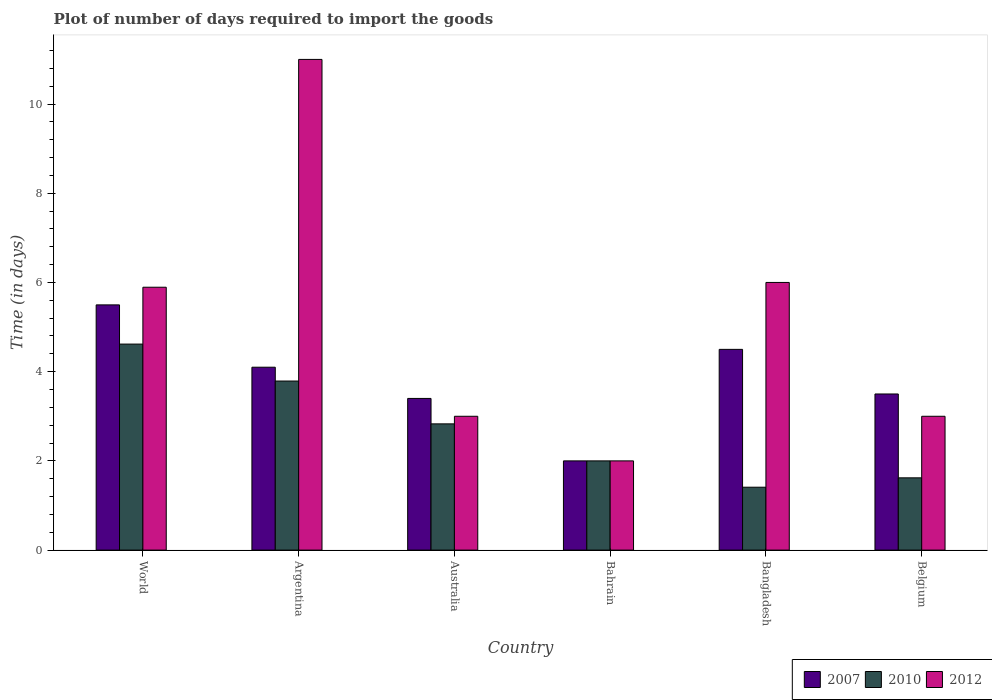How many different coloured bars are there?
Offer a terse response. 3. How many groups of bars are there?
Ensure brevity in your answer.  6. Are the number of bars per tick equal to the number of legend labels?
Keep it short and to the point. Yes. Are the number of bars on each tick of the X-axis equal?
Your response must be concise. Yes. What is the label of the 2nd group of bars from the left?
Offer a terse response. Argentina. What is the time required to import goods in 2010 in Belgium?
Provide a succinct answer. 1.62. Across all countries, what is the maximum time required to import goods in 2012?
Keep it short and to the point. 11. Across all countries, what is the minimum time required to import goods in 2010?
Your answer should be very brief. 1.41. In which country was the time required to import goods in 2012 minimum?
Your response must be concise. Bahrain. What is the total time required to import goods in 2010 in the graph?
Keep it short and to the point. 16.27. What is the difference between the time required to import goods in 2012 in Bahrain and that in Belgium?
Provide a succinct answer. -1. What is the difference between the time required to import goods in 2007 in Bangladesh and the time required to import goods in 2012 in World?
Provide a succinct answer. -1.39. What is the average time required to import goods in 2010 per country?
Ensure brevity in your answer.  2.71. What is the difference between the time required to import goods of/in 2010 and time required to import goods of/in 2007 in Australia?
Provide a succinct answer. -0.57. In how many countries, is the time required to import goods in 2007 greater than 1.6 days?
Your answer should be compact. 6. What is the ratio of the time required to import goods in 2010 in Bangladesh to that in Belgium?
Your answer should be very brief. 0.87. Is the time required to import goods in 2010 in Australia less than that in Bahrain?
Make the answer very short. No. Is the difference between the time required to import goods in 2010 in Argentina and Belgium greater than the difference between the time required to import goods in 2007 in Argentina and Belgium?
Provide a succinct answer. Yes. What is the difference between the highest and the second highest time required to import goods in 2010?
Provide a succinct answer. -0.96. What is the difference between the highest and the lowest time required to import goods in 2010?
Ensure brevity in your answer.  3.21. In how many countries, is the time required to import goods in 2007 greater than the average time required to import goods in 2007 taken over all countries?
Offer a terse response. 3. Is it the case that in every country, the sum of the time required to import goods in 2010 and time required to import goods in 2012 is greater than the time required to import goods in 2007?
Offer a terse response. Yes. How many countries are there in the graph?
Keep it short and to the point. 6. What is the difference between two consecutive major ticks on the Y-axis?
Your answer should be compact. 2. Does the graph contain any zero values?
Your response must be concise. No. Does the graph contain grids?
Ensure brevity in your answer.  No. Where does the legend appear in the graph?
Offer a terse response. Bottom right. What is the title of the graph?
Provide a short and direct response. Plot of number of days required to import the goods. What is the label or title of the X-axis?
Your response must be concise. Country. What is the label or title of the Y-axis?
Keep it short and to the point. Time (in days). What is the Time (in days) of 2007 in World?
Give a very brief answer. 5.5. What is the Time (in days) of 2010 in World?
Make the answer very short. 4.62. What is the Time (in days) of 2012 in World?
Offer a very short reply. 5.89. What is the Time (in days) of 2010 in Argentina?
Offer a very short reply. 3.79. What is the Time (in days) in 2007 in Australia?
Give a very brief answer. 3.4. What is the Time (in days) of 2010 in Australia?
Your response must be concise. 2.83. What is the Time (in days) of 2007 in Bahrain?
Offer a terse response. 2. What is the Time (in days) of 2010 in Bahrain?
Provide a short and direct response. 2. What is the Time (in days) in 2010 in Bangladesh?
Your response must be concise. 1.41. What is the Time (in days) in 2012 in Bangladesh?
Ensure brevity in your answer.  6. What is the Time (in days) in 2007 in Belgium?
Make the answer very short. 3.5. What is the Time (in days) of 2010 in Belgium?
Keep it short and to the point. 1.62. What is the Time (in days) of 2012 in Belgium?
Ensure brevity in your answer.  3. Across all countries, what is the maximum Time (in days) in 2007?
Provide a succinct answer. 5.5. Across all countries, what is the maximum Time (in days) in 2010?
Provide a short and direct response. 4.62. Across all countries, what is the minimum Time (in days) of 2010?
Ensure brevity in your answer.  1.41. Across all countries, what is the minimum Time (in days) in 2012?
Make the answer very short. 2. What is the total Time (in days) of 2007 in the graph?
Your answer should be very brief. 23. What is the total Time (in days) in 2010 in the graph?
Your answer should be compact. 16.27. What is the total Time (in days) in 2012 in the graph?
Your answer should be very brief. 30.89. What is the difference between the Time (in days) of 2007 in World and that in Argentina?
Keep it short and to the point. 1.4. What is the difference between the Time (in days) of 2010 in World and that in Argentina?
Your answer should be compact. 0.83. What is the difference between the Time (in days) of 2012 in World and that in Argentina?
Make the answer very short. -5.11. What is the difference between the Time (in days) in 2007 in World and that in Australia?
Ensure brevity in your answer.  2.1. What is the difference between the Time (in days) of 2010 in World and that in Australia?
Offer a very short reply. 1.79. What is the difference between the Time (in days) of 2012 in World and that in Australia?
Offer a very short reply. 2.89. What is the difference between the Time (in days) of 2007 in World and that in Bahrain?
Offer a terse response. 3.5. What is the difference between the Time (in days) in 2010 in World and that in Bahrain?
Ensure brevity in your answer.  2.62. What is the difference between the Time (in days) of 2012 in World and that in Bahrain?
Provide a short and direct response. 3.89. What is the difference between the Time (in days) in 2010 in World and that in Bangladesh?
Make the answer very short. 3.21. What is the difference between the Time (in days) of 2012 in World and that in Bangladesh?
Your answer should be compact. -0.11. What is the difference between the Time (in days) of 2007 in World and that in Belgium?
Give a very brief answer. 2. What is the difference between the Time (in days) in 2010 in World and that in Belgium?
Offer a terse response. 3. What is the difference between the Time (in days) of 2012 in World and that in Belgium?
Give a very brief answer. 2.89. What is the difference between the Time (in days) of 2010 in Argentina and that in Australia?
Your answer should be compact. 0.96. What is the difference between the Time (in days) in 2007 in Argentina and that in Bahrain?
Make the answer very short. 2.1. What is the difference between the Time (in days) of 2010 in Argentina and that in Bahrain?
Your response must be concise. 1.79. What is the difference between the Time (in days) of 2007 in Argentina and that in Bangladesh?
Offer a terse response. -0.4. What is the difference between the Time (in days) in 2010 in Argentina and that in Bangladesh?
Keep it short and to the point. 2.38. What is the difference between the Time (in days) of 2010 in Argentina and that in Belgium?
Your answer should be compact. 2.17. What is the difference between the Time (in days) in 2012 in Argentina and that in Belgium?
Provide a succinct answer. 8. What is the difference between the Time (in days) in 2007 in Australia and that in Bahrain?
Offer a terse response. 1.4. What is the difference between the Time (in days) of 2010 in Australia and that in Bahrain?
Give a very brief answer. 0.83. What is the difference between the Time (in days) of 2007 in Australia and that in Bangladesh?
Make the answer very short. -1.1. What is the difference between the Time (in days) of 2010 in Australia and that in Bangladesh?
Your answer should be compact. 1.42. What is the difference between the Time (in days) in 2012 in Australia and that in Bangladesh?
Give a very brief answer. -3. What is the difference between the Time (in days) in 2010 in Australia and that in Belgium?
Give a very brief answer. 1.21. What is the difference between the Time (in days) of 2012 in Australia and that in Belgium?
Give a very brief answer. 0. What is the difference between the Time (in days) of 2007 in Bahrain and that in Bangladesh?
Your answer should be compact. -2.5. What is the difference between the Time (in days) in 2010 in Bahrain and that in Bangladesh?
Offer a very short reply. 0.59. What is the difference between the Time (in days) of 2012 in Bahrain and that in Bangladesh?
Give a very brief answer. -4. What is the difference between the Time (in days) in 2010 in Bahrain and that in Belgium?
Offer a very short reply. 0.38. What is the difference between the Time (in days) in 2012 in Bahrain and that in Belgium?
Your response must be concise. -1. What is the difference between the Time (in days) in 2007 in Bangladesh and that in Belgium?
Make the answer very short. 1. What is the difference between the Time (in days) in 2010 in Bangladesh and that in Belgium?
Provide a short and direct response. -0.21. What is the difference between the Time (in days) of 2007 in World and the Time (in days) of 2010 in Argentina?
Give a very brief answer. 1.71. What is the difference between the Time (in days) in 2007 in World and the Time (in days) in 2012 in Argentina?
Your answer should be very brief. -5.5. What is the difference between the Time (in days) in 2010 in World and the Time (in days) in 2012 in Argentina?
Offer a very short reply. -6.38. What is the difference between the Time (in days) of 2007 in World and the Time (in days) of 2010 in Australia?
Keep it short and to the point. 2.67. What is the difference between the Time (in days) of 2007 in World and the Time (in days) of 2012 in Australia?
Your answer should be very brief. 2.5. What is the difference between the Time (in days) of 2010 in World and the Time (in days) of 2012 in Australia?
Offer a very short reply. 1.62. What is the difference between the Time (in days) in 2007 in World and the Time (in days) in 2010 in Bahrain?
Your answer should be very brief. 3.5. What is the difference between the Time (in days) in 2007 in World and the Time (in days) in 2012 in Bahrain?
Your response must be concise. 3.5. What is the difference between the Time (in days) in 2010 in World and the Time (in days) in 2012 in Bahrain?
Your answer should be compact. 2.62. What is the difference between the Time (in days) in 2007 in World and the Time (in days) in 2010 in Bangladesh?
Your answer should be very brief. 4.09. What is the difference between the Time (in days) in 2007 in World and the Time (in days) in 2012 in Bangladesh?
Your answer should be very brief. -0.5. What is the difference between the Time (in days) of 2010 in World and the Time (in days) of 2012 in Bangladesh?
Make the answer very short. -1.38. What is the difference between the Time (in days) of 2007 in World and the Time (in days) of 2010 in Belgium?
Your answer should be very brief. 3.88. What is the difference between the Time (in days) in 2007 in World and the Time (in days) in 2012 in Belgium?
Ensure brevity in your answer.  2.5. What is the difference between the Time (in days) in 2010 in World and the Time (in days) in 2012 in Belgium?
Your response must be concise. 1.62. What is the difference between the Time (in days) in 2007 in Argentina and the Time (in days) in 2010 in Australia?
Your answer should be compact. 1.27. What is the difference between the Time (in days) in 2010 in Argentina and the Time (in days) in 2012 in Australia?
Provide a short and direct response. 0.79. What is the difference between the Time (in days) of 2007 in Argentina and the Time (in days) of 2010 in Bahrain?
Offer a terse response. 2.1. What is the difference between the Time (in days) in 2010 in Argentina and the Time (in days) in 2012 in Bahrain?
Your answer should be very brief. 1.79. What is the difference between the Time (in days) of 2007 in Argentina and the Time (in days) of 2010 in Bangladesh?
Offer a terse response. 2.69. What is the difference between the Time (in days) of 2010 in Argentina and the Time (in days) of 2012 in Bangladesh?
Your response must be concise. -2.21. What is the difference between the Time (in days) of 2007 in Argentina and the Time (in days) of 2010 in Belgium?
Provide a short and direct response. 2.48. What is the difference between the Time (in days) in 2007 in Argentina and the Time (in days) in 2012 in Belgium?
Your answer should be compact. 1.1. What is the difference between the Time (in days) of 2010 in Argentina and the Time (in days) of 2012 in Belgium?
Make the answer very short. 0.79. What is the difference between the Time (in days) of 2007 in Australia and the Time (in days) of 2010 in Bahrain?
Offer a very short reply. 1.4. What is the difference between the Time (in days) in 2007 in Australia and the Time (in days) in 2012 in Bahrain?
Offer a very short reply. 1.4. What is the difference between the Time (in days) of 2010 in Australia and the Time (in days) of 2012 in Bahrain?
Your answer should be compact. 0.83. What is the difference between the Time (in days) of 2007 in Australia and the Time (in days) of 2010 in Bangladesh?
Provide a short and direct response. 1.99. What is the difference between the Time (in days) in 2010 in Australia and the Time (in days) in 2012 in Bangladesh?
Provide a short and direct response. -3.17. What is the difference between the Time (in days) of 2007 in Australia and the Time (in days) of 2010 in Belgium?
Your answer should be compact. 1.78. What is the difference between the Time (in days) in 2010 in Australia and the Time (in days) in 2012 in Belgium?
Ensure brevity in your answer.  -0.17. What is the difference between the Time (in days) in 2007 in Bahrain and the Time (in days) in 2010 in Bangladesh?
Your response must be concise. 0.59. What is the difference between the Time (in days) of 2010 in Bahrain and the Time (in days) of 2012 in Bangladesh?
Offer a terse response. -4. What is the difference between the Time (in days) of 2007 in Bahrain and the Time (in days) of 2010 in Belgium?
Your response must be concise. 0.38. What is the difference between the Time (in days) of 2010 in Bahrain and the Time (in days) of 2012 in Belgium?
Make the answer very short. -1. What is the difference between the Time (in days) in 2007 in Bangladesh and the Time (in days) in 2010 in Belgium?
Give a very brief answer. 2.88. What is the difference between the Time (in days) in 2007 in Bangladesh and the Time (in days) in 2012 in Belgium?
Give a very brief answer. 1.5. What is the difference between the Time (in days) of 2010 in Bangladesh and the Time (in days) of 2012 in Belgium?
Offer a terse response. -1.59. What is the average Time (in days) of 2007 per country?
Your response must be concise. 3.83. What is the average Time (in days) of 2010 per country?
Your response must be concise. 2.71. What is the average Time (in days) of 2012 per country?
Provide a short and direct response. 5.15. What is the difference between the Time (in days) in 2007 and Time (in days) in 2010 in World?
Your answer should be compact. 0.88. What is the difference between the Time (in days) in 2007 and Time (in days) in 2012 in World?
Your answer should be compact. -0.4. What is the difference between the Time (in days) in 2010 and Time (in days) in 2012 in World?
Your answer should be compact. -1.27. What is the difference between the Time (in days) of 2007 and Time (in days) of 2010 in Argentina?
Offer a very short reply. 0.31. What is the difference between the Time (in days) in 2007 and Time (in days) in 2012 in Argentina?
Provide a short and direct response. -6.9. What is the difference between the Time (in days) of 2010 and Time (in days) of 2012 in Argentina?
Your response must be concise. -7.21. What is the difference between the Time (in days) in 2007 and Time (in days) in 2010 in Australia?
Your answer should be very brief. 0.57. What is the difference between the Time (in days) of 2007 and Time (in days) of 2012 in Australia?
Make the answer very short. 0.4. What is the difference between the Time (in days) of 2010 and Time (in days) of 2012 in Australia?
Offer a very short reply. -0.17. What is the difference between the Time (in days) of 2007 and Time (in days) of 2010 in Bahrain?
Offer a very short reply. 0. What is the difference between the Time (in days) of 2007 and Time (in days) of 2012 in Bahrain?
Provide a succinct answer. 0. What is the difference between the Time (in days) of 2010 and Time (in days) of 2012 in Bahrain?
Your response must be concise. 0. What is the difference between the Time (in days) of 2007 and Time (in days) of 2010 in Bangladesh?
Give a very brief answer. 3.09. What is the difference between the Time (in days) in 2010 and Time (in days) in 2012 in Bangladesh?
Keep it short and to the point. -4.59. What is the difference between the Time (in days) in 2007 and Time (in days) in 2010 in Belgium?
Provide a short and direct response. 1.88. What is the difference between the Time (in days) in 2007 and Time (in days) in 2012 in Belgium?
Keep it short and to the point. 0.5. What is the difference between the Time (in days) in 2010 and Time (in days) in 2012 in Belgium?
Your response must be concise. -1.38. What is the ratio of the Time (in days) in 2007 in World to that in Argentina?
Make the answer very short. 1.34. What is the ratio of the Time (in days) in 2010 in World to that in Argentina?
Provide a short and direct response. 1.22. What is the ratio of the Time (in days) in 2012 in World to that in Argentina?
Your answer should be very brief. 0.54. What is the ratio of the Time (in days) in 2007 in World to that in Australia?
Give a very brief answer. 1.62. What is the ratio of the Time (in days) of 2010 in World to that in Australia?
Your answer should be compact. 1.63. What is the ratio of the Time (in days) of 2012 in World to that in Australia?
Provide a short and direct response. 1.96. What is the ratio of the Time (in days) in 2007 in World to that in Bahrain?
Give a very brief answer. 2.75. What is the ratio of the Time (in days) in 2010 in World to that in Bahrain?
Provide a succinct answer. 2.31. What is the ratio of the Time (in days) in 2012 in World to that in Bahrain?
Ensure brevity in your answer.  2.95. What is the ratio of the Time (in days) of 2007 in World to that in Bangladesh?
Give a very brief answer. 1.22. What is the ratio of the Time (in days) of 2010 in World to that in Bangladesh?
Make the answer very short. 3.28. What is the ratio of the Time (in days) of 2012 in World to that in Bangladesh?
Make the answer very short. 0.98. What is the ratio of the Time (in days) of 2007 in World to that in Belgium?
Your response must be concise. 1.57. What is the ratio of the Time (in days) in 2010 in World to that in Belgium?
Your answer should be very brief. 2.85. What is the ratio of the Time (in days) of 2012 in World to that in Belgium?
Your answer should be very brief. 1.96. What is the ratio of the Time (in days) in 2007 in Argentina to that in Australia?
Ensure brevity in your answer.  1.21. What is the ratio of the Time (in days) in 2010 in Argentina to that in Australia?
Keep it short and to the point. 1.34. What is the ratio of the Time (in days) of 2012 in Argentina to that in Australia?
Provide a short and direct response. 3.67. What is the ratio of the Time (in days) of 2007 in Argentina to that in Bahrain?
Your answer should be compact. 2.05. What is the ratio of the Time (in days) of 2010 in Argentina to that in Bahrain?
Your answer should be very brief. 1.9. What is the ratio of the Time (in days) of 2012 in Argentina to that in Bahrain?
Offer a terse response. 5.5. What is the ratio of the Time (in days) in 2007 in Argentina to that in Bangladesh?
Make the answer very short. 0.91. What is the ratio of the Time (in days) in 2010 in Argentina to that in Bangladesh?
Give a very brief answer. 2.69. What is the ratio of the Time (in days) in 2012 in Argentina to that in Bangladesh?
Provide a succinct answer. 1.83. What is the ratio of the Time (in days) of 2007 in Argentina to that in Belgium?
Offer a terse response. 1.17. What is the ratio of the Time (in days) of 2010 in Argentina to that in Belgium?
Keep it short and to the point. 2.34. What is the ratio of the Time (in days) in 2012 in Argentina to that in Belgium?
Your answer should be compact. 3.67. What is the ratio of the Time (in days) of 2007 in Australia to that in Bahrain?
Ensure brevity in your answer.  1.7. What is the ratio of the Time (in days) of 2010 in Australia to that in Bahrain?
Offer a very short reply. 1.42. What is the ratio of the Time (in days) of 2007 in Australia to that in Bangladesh?
Your response must be concise. 0.76. What is the ratio of the Time (in days) of 2010 in Australia to that in Bangladesh?
Provide a succinct answer. 2.01. What is the ratio of the Time (in days) of 2012 in Australia to that in Bangladesh?
Provide a short and direct response. 0.5. What is the ratio of the Time (in days) in 2007 in Australia to that in Belgium?
Provide a short and direct response. 0.97. What is the ratio of the Time (in days) of 2010 in Australia to that in Belgium?
Ensure brevity in your answer.  1.75. What is the ratio of the Time (in days) of 2007 in Bahrain to that in Bangladesh?
Provide a short and direct response. 0.44. What is the ratio of the Time (in days) of 2010 in Bahrain to that in Bangladesh?
Provide a short and direct response. 1.42. What is the ratio of the Time (in days) in 2012 in Bahrain to that in Bangladesh?
Keep it short and to the point. 0.33. What is the ratio of the Time (in days) of 2007 in Bahrain to that in Belgium?
Make the answer very short. 0.57. What is the ratio of the Time (in days) in 2010 in Bahrain to that in Belgium?
Your answer should be compact. 1.23. What is the ratio of the Time (in days) in 2012 in Bahrain to that in Belgium?
Ensure brevity in your answer.  0.67. What is the ratio of the Time (in days) of 2007 in Bangladesh to that in Belgium?
Your response must be concise. 1.29. What is the ratio of the Time (in days) in 2010 in Bangladesh to that in Belgium?
Your response must be concise. 0.87. What is the difference between the highest and the second highest Time (in days) in 2007?
Ensure brevity in your answer.  1. What is the difference between the highest and the second highest Time (in days) of 2010?
Make the answer very short. 0.83. What is the difference between the highest and the lowest Time (in days) in 2007?
Ensure brevity in your answer.  3.5. What is the difference between the highest and the lowest Time (in days) in 2010?
Your answer should be compact. 3.21. 